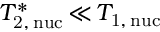Convert formula to latex. <formula><loc_0><loc_0><loc_500><loc_500>T _ { 2 , \, n u c } ^ { \ast } \, { \ll } \, T _ { 1 , \, n u c }</formula> 